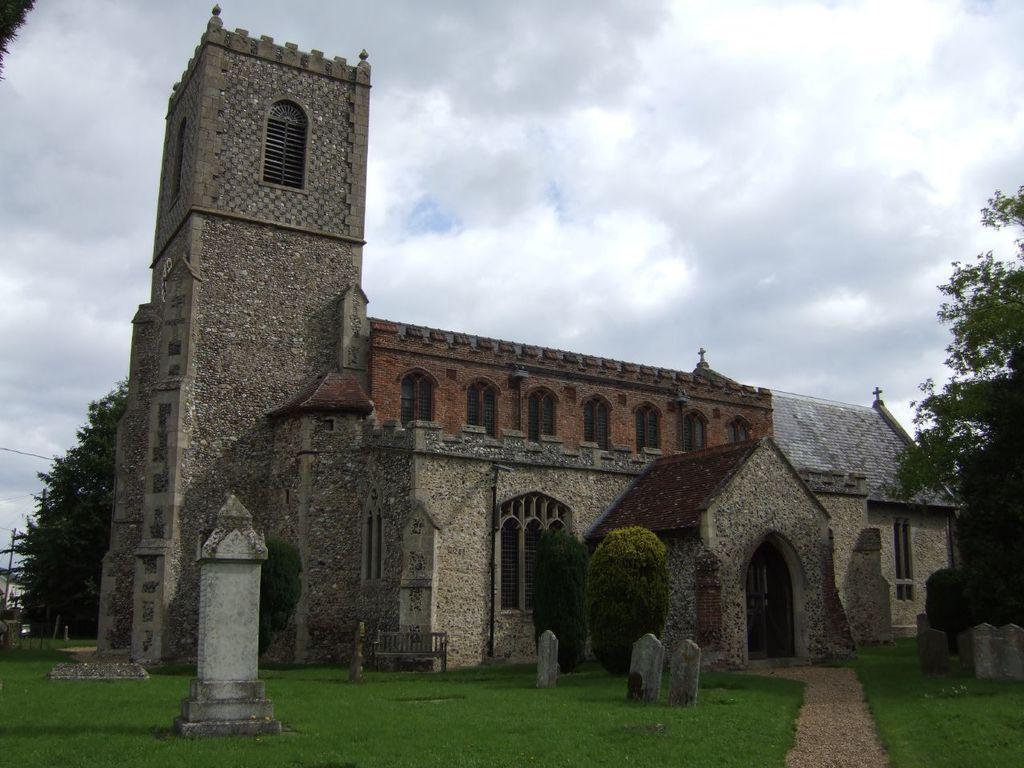How would you summarize this image in a sentence or two? At the bottom of the image on the ground there is grass. And also there are graves and pillars. Behind them there are bushes and trees. There is a building with walls, windows, arched, doors, roofs and pillars. At the top of the image there is sky with clouds. On the left side of the image there are trees. 